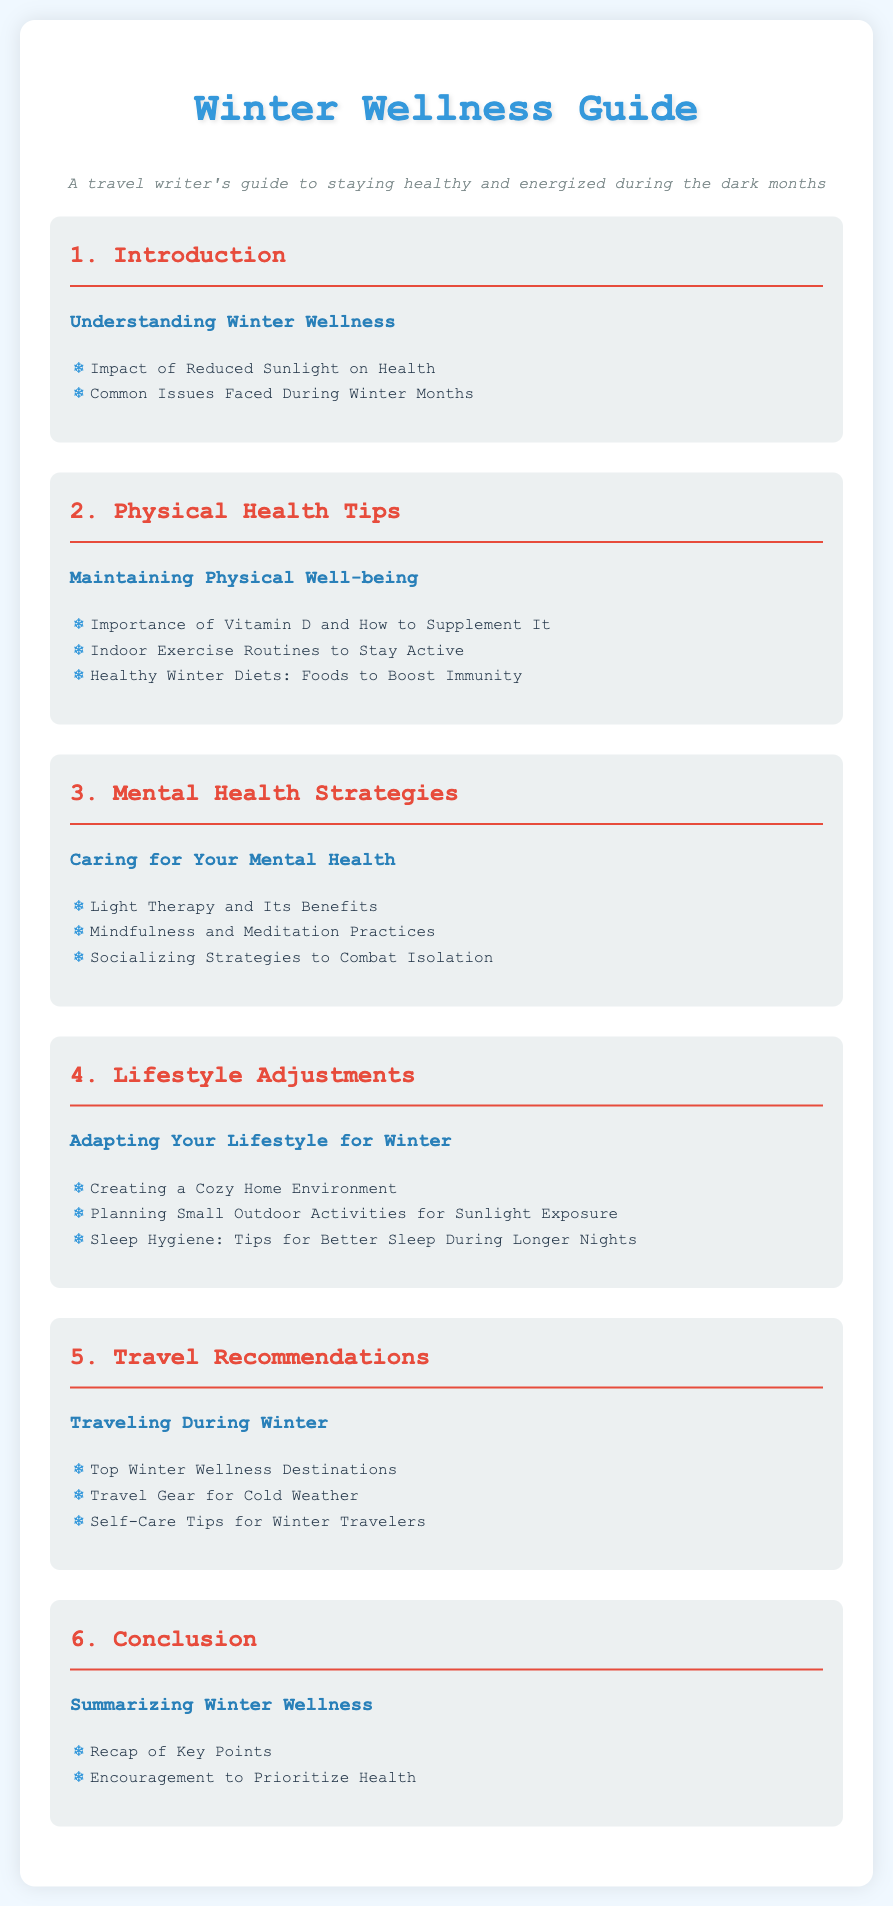What is the title of the document? The title is found in the header section of the document, which introduces the main topic.
Answer: Winter Wellness Guide How many sections are in the guide? The number of sections can be counted based on the headings listed in the document.
Answer: 6 What is one suggested strategy to combat isolation in winter? The document lists strategies for mental health that include connecting with others.
Answer: Socializing Strategies to Combat Isolation What type of exercise routines are recommended? The section on physical health tips mentions specific types of physical activity ideal for winter months.
Answer: Indoor Exercise Routines to Stay Active What is a benefit of light therapy? The document highlights the advantages of using light therapy for mental health during winter.
Answer: Its Benefits What should you consider for a cozy home environment? One of the lifestyle adjustments discussed involves creating a comfortable domestic atmosphere.
Answer: Creating a Cozy Home Environment How can you supplement Vitamin D? The document refers to methods for addressing vitamin D needs effectively in winter wellness.
Answer: How to Supplement It What feature enhances the document's visual appeal in each section? Each section's design includes a hover effect that makes it visually engaging.
Answer: Transition Effects Which section focuses on traveling during winter? A specific section is dedicated to providing guidance on travel-related topics in winter conditions.
Answer: 5. Travel Recommendations 